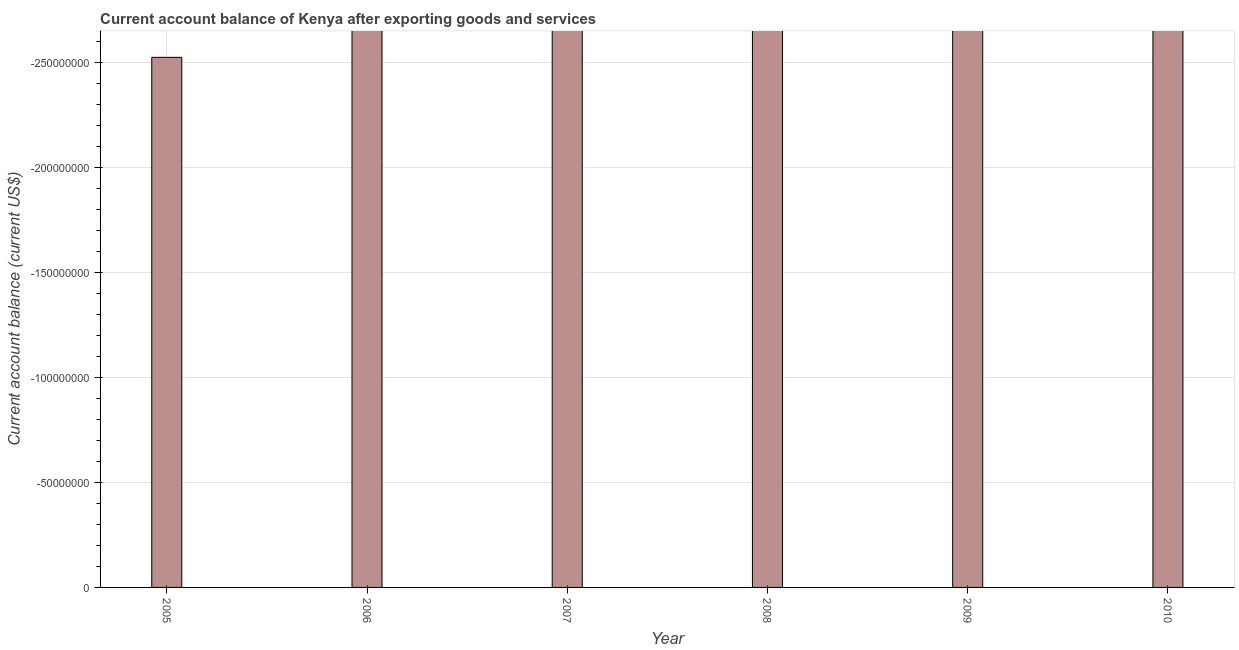Does the graph contain any zero values?
Make the answer very short. Yes. Does the graph contain grids?
Make the answer very short. Yes. What is the title of the graph?
Offer a very short reply. Current account balance of Kenya after exporting goods and services. What is the label or title of the X-axis?
Your answer should be very brief. Year. What is the label or title of the Y-axis?
Keep it short and to the point. Current account balance (current US$). What is the average current account balance per year?
Give a very brief answer. 0. What is the median current account balance?
Your response must be concise. 0. In how many years, is the current account balance greater than the average current account balance taken over all years?
Ensure brevity in your answer.  0. How many bars are there?
Your answer should be compact. 0. Are all the bars in the graph horizontal?
Offer a very short reply. No. What is the difference between two consecutive major ticks on the Y-axis?
Provide a succinct answer. 5.00e+07. What is the Current account balance (current US$) of 2009?
Your response must be concise. 0. 